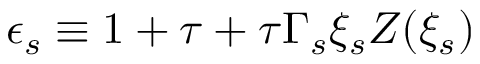<formula> <loc_0><loc_0><loc_500><loc_500>\epsilon _ { s } \equiv 1 + \tau + \tau \Gamma _ { s } \xi _ { s } Z ( \xi _ { s } )</formula> 